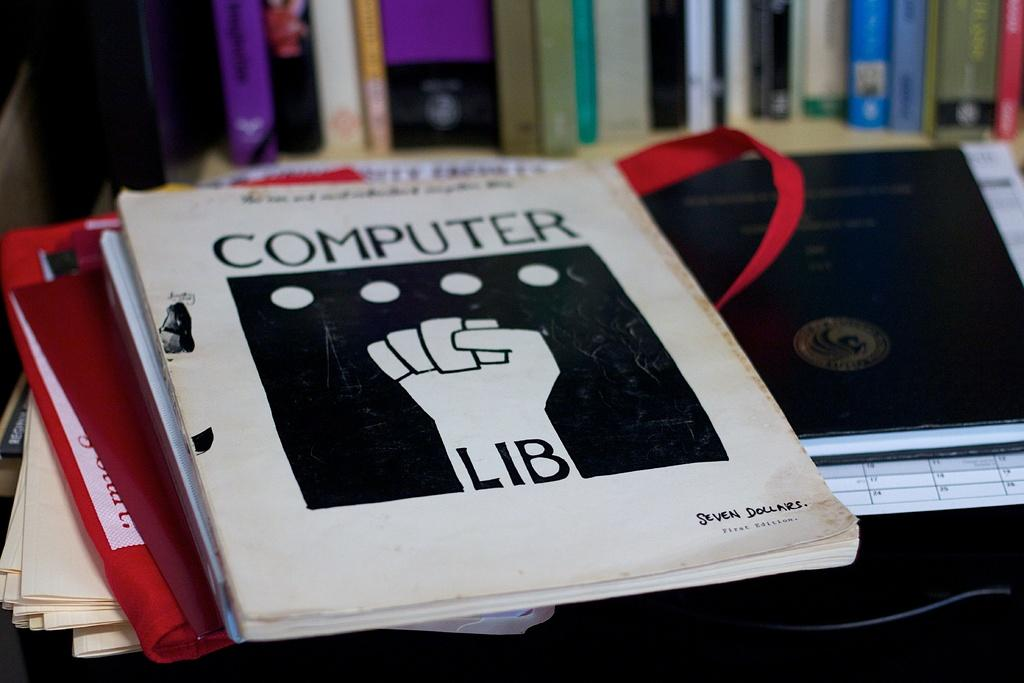What objects are placed on the table in the image? There are books placed on the table in the image. What can be seen in the background of the image? There is a bookshelf in the backdrop of the image. How are the books arranged on the bookshelf? The books are arranged on the bookshelf. What type of bomb can be seen on the bookshelf in the image? There is no bomb present on the bookshelf or in the image. 